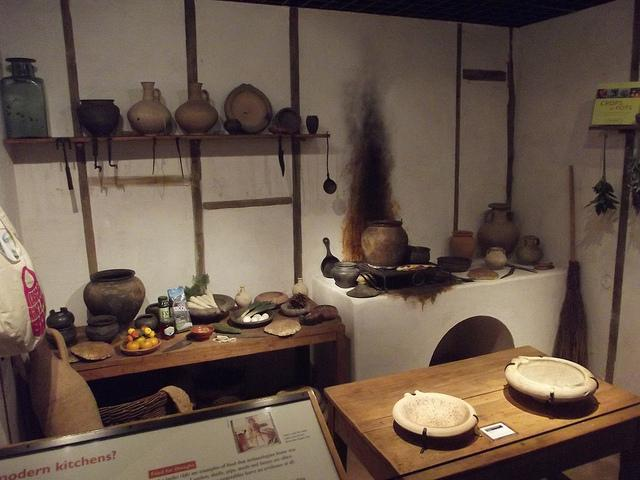In what type building is this located? museum 